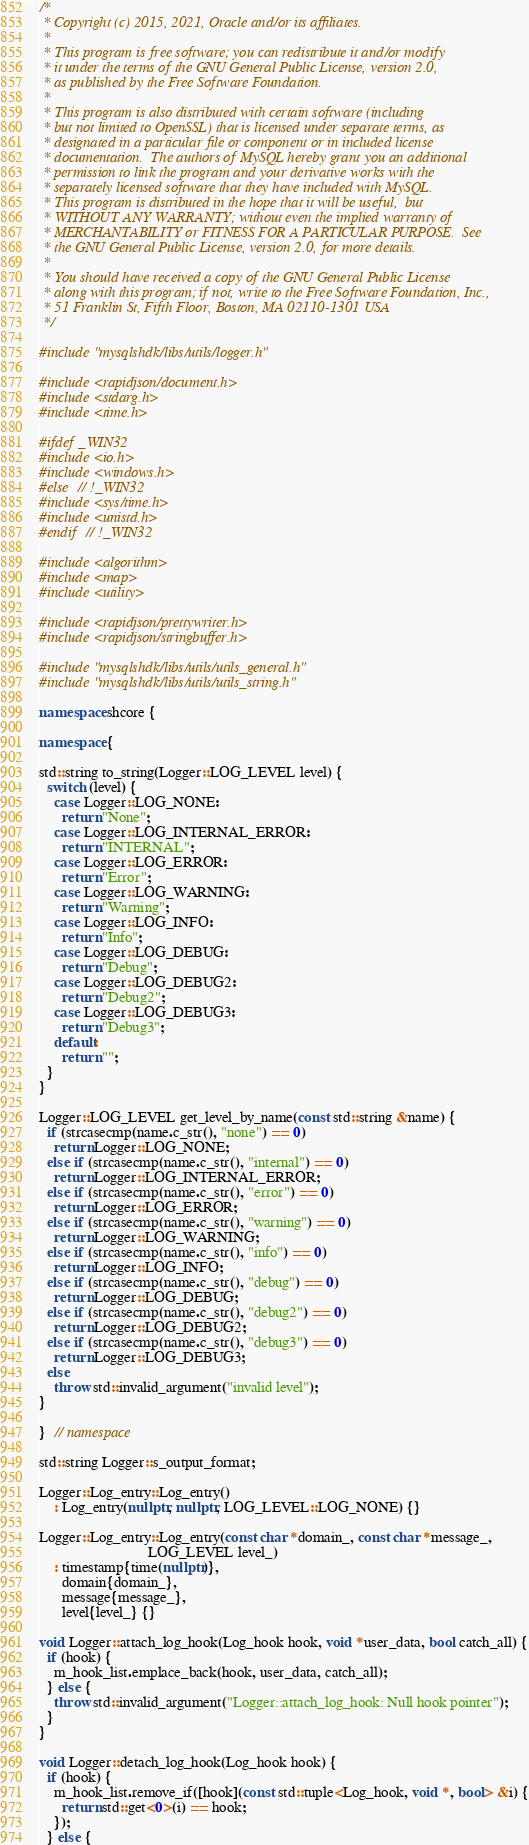<code> <loc_0><loc_0><loc_500><loc_500><_C++_>/*
 * Copyright (c) 2015, 2021, Oracle and/or its affiliates.
 *
 * This program is free software; you can redistribute it and/or modify
 * it under the terms of the GNU General Public License, version 2.0,
 * as published by the Free Software Foundation.
 *
 * This program is also distributed with certain software (including
 * but not limited to OpenSSL) that is licensed under separate terms, as
 * designated in a particular file or component or in included license
 * documentation.  The authors of MySQL hereby grant you an additional
 * permission to link the program and your derivative works with the
 * separately licensed software that they have included with MySQL.
 * This program is distributed in the hope that it will be useful,  but
 * WITHOUT ANY WARRANTY; without even the implied warranty of
 * MERCHANTABILITY or FITNESS FOR A PARTICULAR PURPOSE.  See
 * the GNU General Public License, version 2.0, for more details.
 *
 * You should have received a copy of the GNU General Public License
 * along with this program; if not, write to the Free Software Foundation, Inc.,
 * 51 Franklin St, Fifth Floor, Boston, MA 02110-1301 USA
 */

#include "mysqlshdk/libs/utils/logger.h"

#include <rapidjson/document.h>
#include <stdarg.h>
#include <time.h>

#ifdef _WIN32
#include <io.h>
#include <windows.h>
#else  // !_WIN32
#include <sys/time.h>
#include <unistd.h>
#endif  // !_WIN32

#include <algorithm>
#include <map>
#include <utility>

#include <rapidjson/prettywriter.h>
#include <rapidjson/stringbuffer.h>

#include "mysqlshdk/libs/utils/utils_general.h"
#include "mysqlshdk/libs/utils/utils_string.h"

namespace shcore {

namespace {

std::string to_string(Logger::LOG_LEVEL level) {
  switch (level) {
    case Logger::LOG_NONE:
      return "None";
    case Logger::LOG_INTERNAL_ERROR:
      return "INTERNAL";
    case Logger::LOG_ERROR:
      return "Error";
    case Logger::LOG_WARNING:
      return "Warning";
    case Logger::LOG_INFO:
      return "Info";
    case Logger::LOG_DEBUG:
      return "Debug";
    case Logger::LOG_DEBUG2:
      return "Debug2";
    case Logger::LOG_DEBUG3:
      return "Debug3";
    default:
      return "";
  }
}

Logger::LOG_LEVEL get_level_by_name(const std::string &name) {
  if (strcasecmp(name.c_str(), "none") == 0)
    return Logger::LOG_NONE;
  else if (strcasecmp(name.c_str(), "internal") == 0)
    return Logger::LOG_INTERNAL_ERROR;
  else if (strcasecmp(name.c_str(), "error") == 0)
    return Logger::LOG_ERROR;
  else if (strcasecmp(name.c_str(), "warning") == 0)
    return Logger::LOG_WARNING;
  else if (strcasecmp(name.c_str(), "info") == 0)
    return Logger::LOG_INFO;
  else if (strcasecmp(name.c_str(), "debug") == 0)
    return Logger::LOG_DEBUG;
  else if (strcasecmp(name.c_str(), "debug2") == 0)
    return Logger::LOG_DEBUG2;
  else if (strcasecmp(name.c_str(), "debug3") == 0)
    return Logger::LOG_DEBUG3;
  else
    throw std::invalid_argument("invalid level");
}

}  // namespace

std::string Logger::s_output_format;

Logger::Log_entry::Log_entry()
    : Log_entry(nullptr, nullptr, LOG_LEVEL::LOG_NONE) {}

Logger::Log_entry::Log_entry(const char *domain_, const char *message_,
                             LOG_LEVEL level_)
    : timestamp{time(nullptr)},
      domain{domain_},
      message{message_},
      level{level_} {}

void Logger::attach_log_hook(Log_hook hook, void *user_data, bool catch_all) {
  if (hook) {
    m_hook_list.emplace_back(hook, user_data, catch_all);
  } else {
    throw std::invalid_argument("Logger::attach_log_hook: Null hook pointer");
  }
}

void Logger::detach_log_hook(Log_hook hook) {
  if (hook) {
    m_hook_list.remove_if([hook](const std::tuple<Log_hook, void *, bool> &i) {
      return std::get<0>(i) == hook;
    });
  } else {</code> 